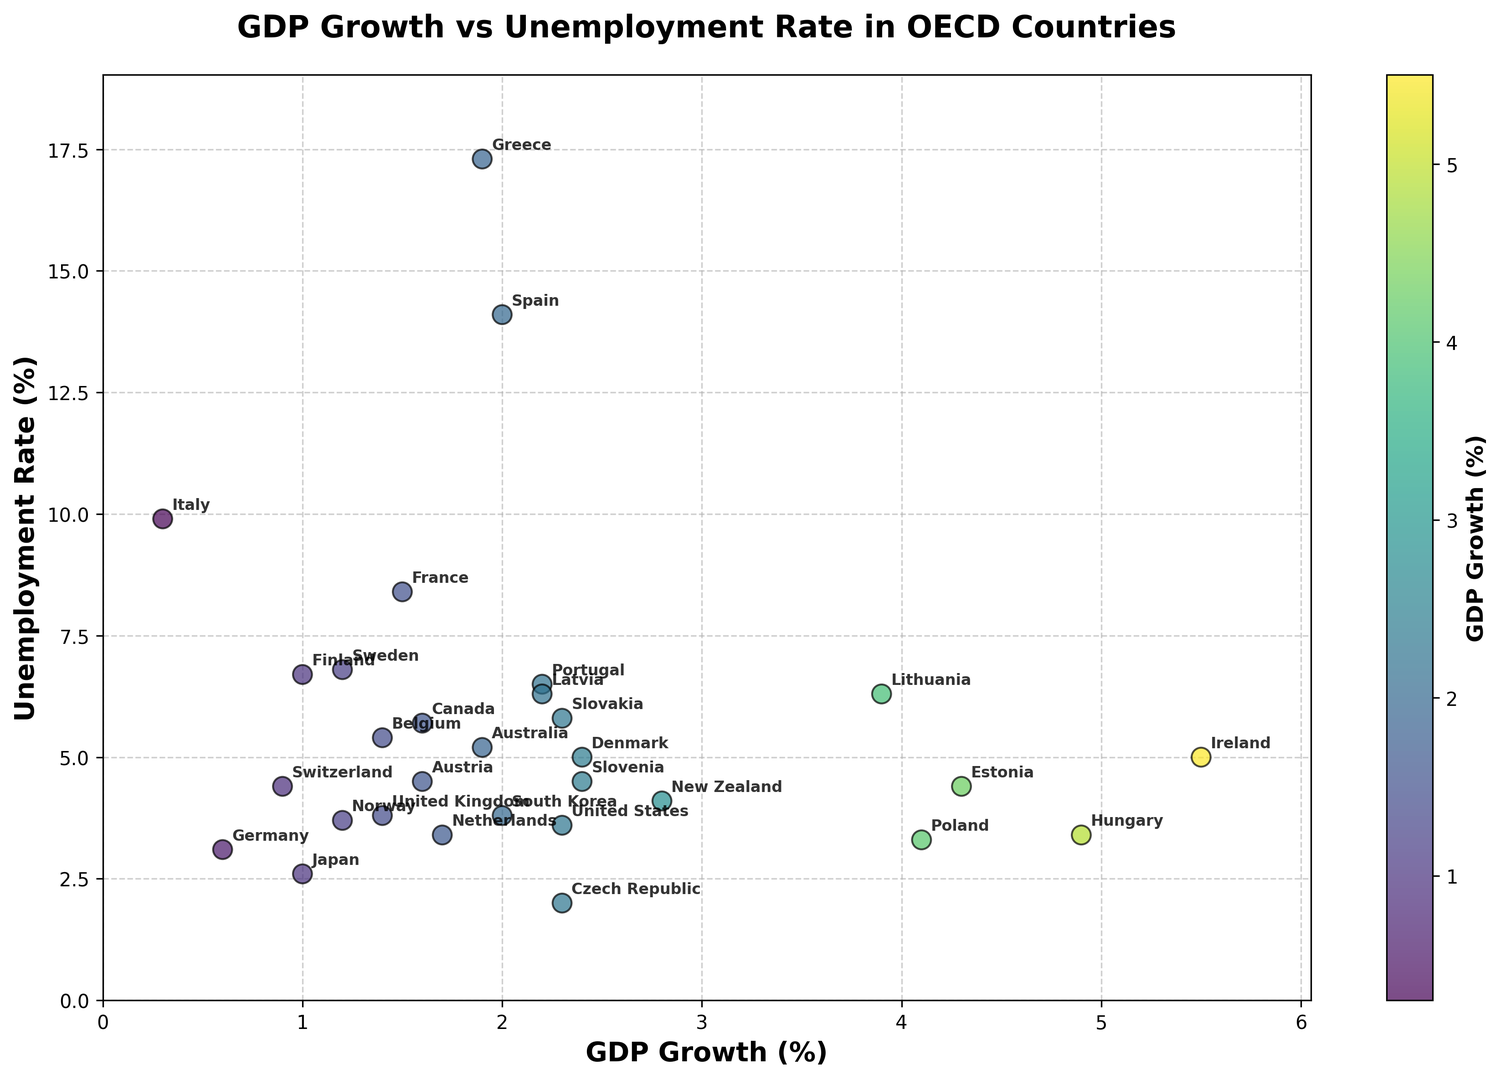Which country has the highest GDP growth rate? To find the country with the highest GDP growth rate, look for the data point positioned farthest to the right on the x-axis. This position corresponds to the country with the highest GDP growth rate.
Answer: Ireland Which country has the highest unemployment rate, and what is its GDP growth rate? Identify the data point located the highest on the y-axis. This is the country with the highest unemployment rate. Then read its corresponding x-axis value for the GDP growth rate.
Answer: Greece, 1.9% Which countries have GDP growth rates between 1% and 2% and how do their unemployment rates compare? Find the countries with GDP growth rates within the range of 1% to 2% on the x-axis. Then, compare the y-axis values (unemployment rates) for these countries.
Answer: Japan, United Kingdom, France, Canada, Australia, Switzerland, Sweden, Norway, Portugal, Latvia. Their unemployment rates vary, with Portugal having the highest unemployment rate among them What is the correlation between GDP growth and unemployment rates? To determine the correlation, observe the overall trend in the scatter plot. If points tend to increase in one direction, it suggests a positive or negative correlation. In this case, higher GDP growth rates generally coincide with lower unemployment rates, indicating a negative correlation.
Answer: Negative correlation Which country's data point lies nearest to the origin, and what do its GDP growth and unemployment rates indicate? Locate the data point closest to the origin (0,0). This represents the country with both the smallest GDP growth rate and unemployment rate. Read the corresponding values for this data point.
Answer: Czech Republic, 2.3% GDP growth and 2.0% unemployment rate How does Japan's unemployment rate compare to the average unemployment rate of countries with GDP growth rates greater than 2%? Identify Japan's data point and its unemployment rate. Calculate the average unemployment rate of countries with GDP growth rates higher than 2% and compare it to Japan's value. Step-by-step: Japan's unemployment rate is 2.6%. High GDP growth countries: US (3.6%), Denmark (5.0%), New Zealand (4.1%), Czech Republic (2.0%), Hungary (3.4%), Poland (3.3%), Slovakia (5.8%), Slovenia (4.5%), Estonia (4.4%), Lithuania (6.3%). Average = (3.6+5.0+4.1+2.0+3.4+3.3+5.8+4.5+4.4+6.3)/10 = 4.2%.
Answer: Japan's unemployment rate is lower Which country shows the least unemployment rate among those with GDP growth rates greater than 3%? Identify countries with GDP growth rates greater than 3% and then find the one with the lowest unemployment rate among them.
Answer: Czech Republic How do the GDP growth rates differ between the United States and Germany? Locate the data points for the United States and Germany, then subtract Germany's GDP growth rate from that of the United States. The steps are: United States (2.3%) - Germany (0.6%).
Answer: 1.7% What are the unemployment rates of countries with the top 3 GDP growth rates? Identify the countries with the top 3 GDP growth rates, then find their corresponding unemployment rates. The top 3 countries by GDP growth are Ireland, Hungary, and Estonia. Their unemployment rates are: Ireland (5.0%), Hungary (3.4%), and Estonia (4.4%).
Answer: 5.0%, 3.4%, 4.4% What trend do you observe for countries with GDP growth rates less than 1.5% regarding their unemployment rates? Identify the countries with GDP growth rates less than 1.5% and observe their corresponding unemployment rates. Generally: Germany (3.1%), Japan (2.6%), Switzerland (4.4%), Italy (9.9%), Sweden (6.8%), Finland (6.7%). Most have moderate to high unemployment rates, with Finland, Sweden, and Italy notably high.
Answer: Moderate to high unemployment rates, with several notably high 